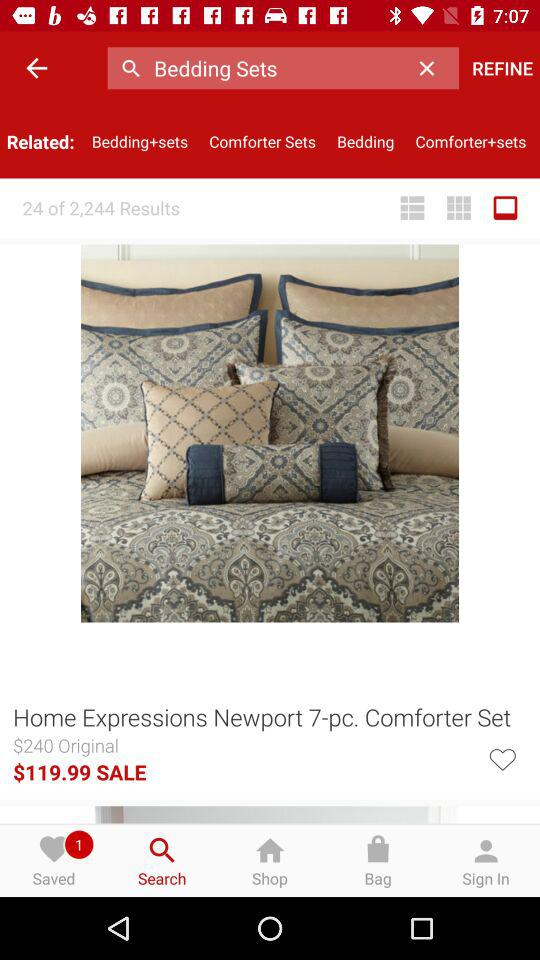How much is the sale price of the comforter set?
Answer the question using a single word or phrase. $119.99 